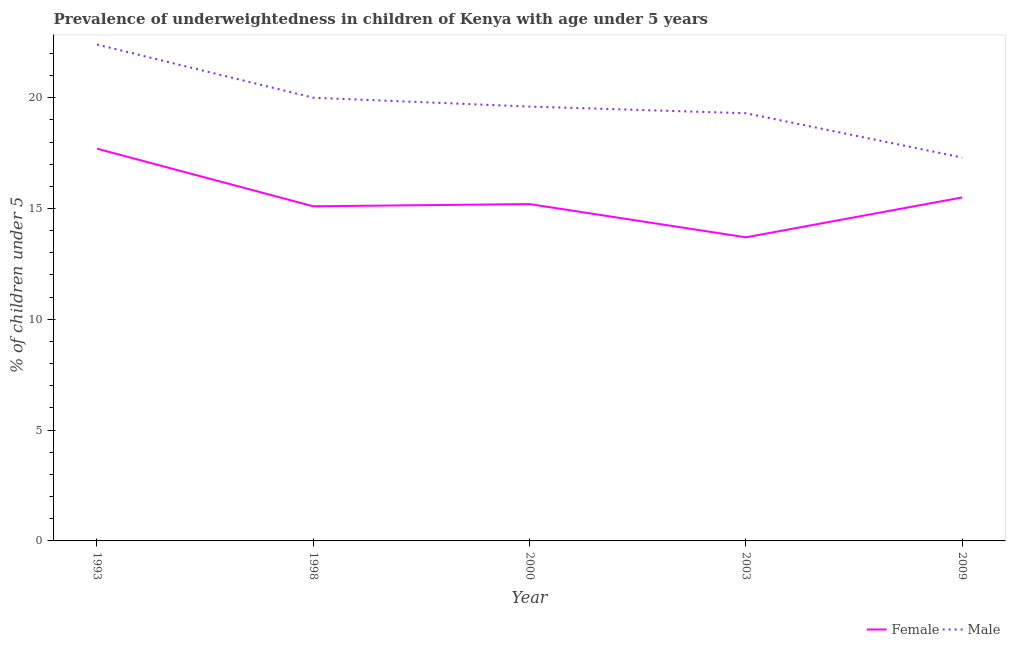How many different coloured lines are there?
Make the answer very short. 2. Is the number of lines equal to the number of legend labels?
Offer a terse response. Yes. What is the percentage of underweighted male children in 2000?
Ensure brevity in your answer.  19.6. Across all years, what is the maximum percentage of underweighted female children?
Keep it short and to the point. 17.7. Across all years, what is the minimum percentage of underweighted male children?
Offer a terse response. 17.3. In which year was the percentage of underweighted male children minimum?
Your answer should be compact. 2009. What is the total percentage of underweighted female children in the graph?
Make the answer very short. 77.2. What is the difference between the percentage of underweighted male children in 1993 and that in 1998?
Offer a very short reply. 2.4. What is the difference between the percentage of underweighted male children in 1998 and the percentage of underweighted female children in 2000?
Ensure brevity in your answer.  4.8. What is the average percentage of underweighted male children per year?
Keep it short and to the point. 19.72. In the year 2003, what is the difference between the percentage of underweighted male children and percentage of underweighted female children?
Ensure brevity in your answer.  5.6. What is the ratio of the percentage of underweighted female children in 1993 to that in 2000?
Keep it short and to the point. 1.16. Is the percentage of underweighted male children in 1993 less than that in 1998?
Provide a succinct answer. No. What is the difference between the highest and the second highest percentage of underweighted male children?
Keep it short and to the point. 2.4. What is the difference between the highest and the lowest percentage of underweighted male children?
Your response must be concise. 5.1. In how many years, is the percentage of underweighted male children greater than the average percentage of underweighted male children taken over all years?
Offer a very short reply. 2. Does the percentage of underweighted female children monotonically increase over the years?
Ensure brevity in your answer.  No. What is the difference between two consecutive major ticks on the Y-axis?
Offer a terse response. 5. How are the legend labels stacked?
Provide a succinct answer. Horizontal. What is the title of the graph?
Make the answer very short. Prevalence of underweightedness in children of Kenya with age under 5 years. Does "Short-term debt" appear as one of the legend labels in the graph?
Give a very brief answer. No. What is the label or title of the X-axis?
Your answer should be very brief. Year. What is the label or title of the Y-axis?
Give a very brief answer.  % of children under 5. What is the  % of children under 5 in Female in 1993?
Offer a very short reply. 17.7. What is the  % of children under 5 in Male in 1993?
Make the answer very short. 22.4. What is the  % of children under 5 in Female in 1998?
Your answer should be compact. 15.1. What is the  % of children under 5 in Female in 2000?
Offer a very short reply. 15.2. What is the  % of children under 5 in Male in 2000?
Your answer should be compact. 19.6. What is the  % of children under 5 in Female in 2003?
Your response must be concise. 13.7. What is the  % of children under 5 of Male in 2003?
Provide a short and direct response. 19.3. What is the  % of children under 5 of Male in 2009?
Keep it short and to the point. 17.3. Across all years, what is the maximum  % of children under 5 in Female?
Keep it short and to the point. 17.7. Across all years, what is the maximum  % of children under 5 in Male?
Make the answer very short. 22.4. Across all years, what is the minimum  % of children under 5 of Female?
Give a very brief answer. 13.7. Across all years, what is the minimum  % of children under 5 in Male?
Your answer should be very brief. 17.3. What is the total  % of children under 5 of Female in the graph?
Your answer should be very brief. 77.2. What is the total  % of children under 5 in Male in the graph?
Offer a very short reply. 98.6. What is the difference between the  % of children under 5 in Female in 1993 and that in 1998?
Provide a short and direct response. 2.6. What is the difference between the  % of children under 5 in Male in 1993 and that in 1998?
Give a very brief answer. 2.4. What is the difference between the  % of children under 5 of Male in 1993 and that in 2000?
Make the answer very short. 2.8. What is the difference between the  % of children under 5 of Female in 1993 and that in 2003?
Your response must be concise. 4. What is the difference between the  % of children under 5 in Female in 1993 and that in 2009?
Make the answer very short. 2.2. What is the difference between the  % of children under 5 of Male in 1993 and that in 2009?
Ensure brevity in your answer.  5.1. What is the difference between the  % of children under 5 in Male in 1998 and that in 2000?
Give a very brief answer. 0.4. What is the difference between the  % of children under 5 of Female in 2000 and that in 2003?
Your answer should be very brief. 1.5. What is the difference between the  % of children under 5 in Male in 2000 and that in 2003?
Your answer should be compact. 0.3. What is the difference between the  % of children under 5 of Female in 2000 and that in 2009?
Offer a very short reply. -0.3. What is the difference between the  % of children under 5 in Male in 2000 and that in 2009?
Your answer should be very brief. 2.3. What is the difference between the  % of children under 5 of Male in 2003 and that in 2009?
Ensure brevity in your answer.  2. What is the difference between the  % of children under 5 in Female in 1993 and the  % of children under 5 in Male in 2009?
Make the answer very short. 0.4. What is the difference between the  % of children under 5 in Female in 1998 and the  % of children under 5 in Male in 2003?
Ensure brevity in your answer.  -4.2. What is the difference between the  % of children under 5 of Female in 1998 and the  % of children under 5 of Male in 2009?
Provide a succinct answer. -2.2. What is the difference between the  % of children under 5 in Female in 2000 and the  % of children under 5 in Male in 2003?
Keep it short and to the point. -4.1. What is the difference between the  % of children under 5 in Female in 2000 and the  % of children under 5 in Male in 2009?
Offer a very short reply. -2.1. What is the average  % of children under 5 of Female per year?
Offer a very short reply. 15.44. What is the average  % of children under 5 in Male per year?
Make the answer very short. 19.72. In the year 1998, what is the difference between the  % of children under 5 of Female and  % of children under 5 of Male?
Your answer should be compact. -4.9. In the year 2003, what is the difference between the  % of children under 5 in Female and  % of children under 5 in Male?
Keep it short and to the point. -5.6. What is the ratio of the  % of children under 5 in Female in 1993 to that in 1998?
Provide a succinct answer. 1.17. What is the ratio of the  % of children under 5 of Male in 1993 to that in 1998?
Offer a terse response. 1.12. What is the ratio of the  % of children under 5 in Female in 1993 to that in 2000?
Provide a short and direct response. 1.16. What is the ratio of the  % of children under 5 of Female in 1993 to that in 2003?
Keep it short and to the point. 1.29. What is the ratio of the  % of children under 5 in Male in 1993 to that in 2003?
Your answer should be very brief. 1.16. What is the ratio of the  % of children under 5 in Female in 1993 to that in 2009?
Provide a succinct answer. 1.14. What is the ratio of the  % of children under 5 of Male in 1993 to that in 2009?
Make the answer very short. 1.29. What is the ratio of the  % of children under 5 in Female in 1998 to that in 2000?
Offer a very short reply. 0.99. What is the ratio of the  % of children under 5 of Male in 1998 to that in 2000?
Your answer should be compact. 1.02. What is the ratio of the  % of children under 5 of Female in 1998 to that in 2003?
Offer a terse response. 1.1. What is the ratio of the  % of children under 5 in Male in 1998 to that in 2003?
Ensure brevity in your answer.  1.04. What is the ratio of the  % of children under 5 in Female in 1998 to that in 2009?
Keep it short and to the point. 0.97. What is the ratio of the  % of children under 5 in Male in 1998 to that in 2009?
Offer a very short reply. 1.16. What is the ratio of the  % of children under 5 of Female in 2000 to that in 2003?
Provide a succinct answer. 1.11. What is the ratio of the  % of children under 5 in Male in 2000 to that in 2003?
Offer a very short reply. 1.02. What is the ratio of the  % of children under 5 in Female in 2000 to that in 2009?
Provide a succinct answer. 0.98. What is the ratio of the  % of children under 5 of Male in 2000 to that in 2009?
Provide a succinct answer. 1.13. What is the ratio of the  % of children under 5 of Female in 2003 to that in 2009?
Keep it short and to the point. 0.88. What is the ratio of the  % of children under 5 in Male in 2003 to that in 2009?
Your answer should be compact. 1.12. What is the difference between the highest and the lowest  % of children under 5 in Female?
Your response must be concise. 4. What is the difference between the highest and the lowest  % of children under 5 of Male?
Keep it short and to the point. 5.1. 